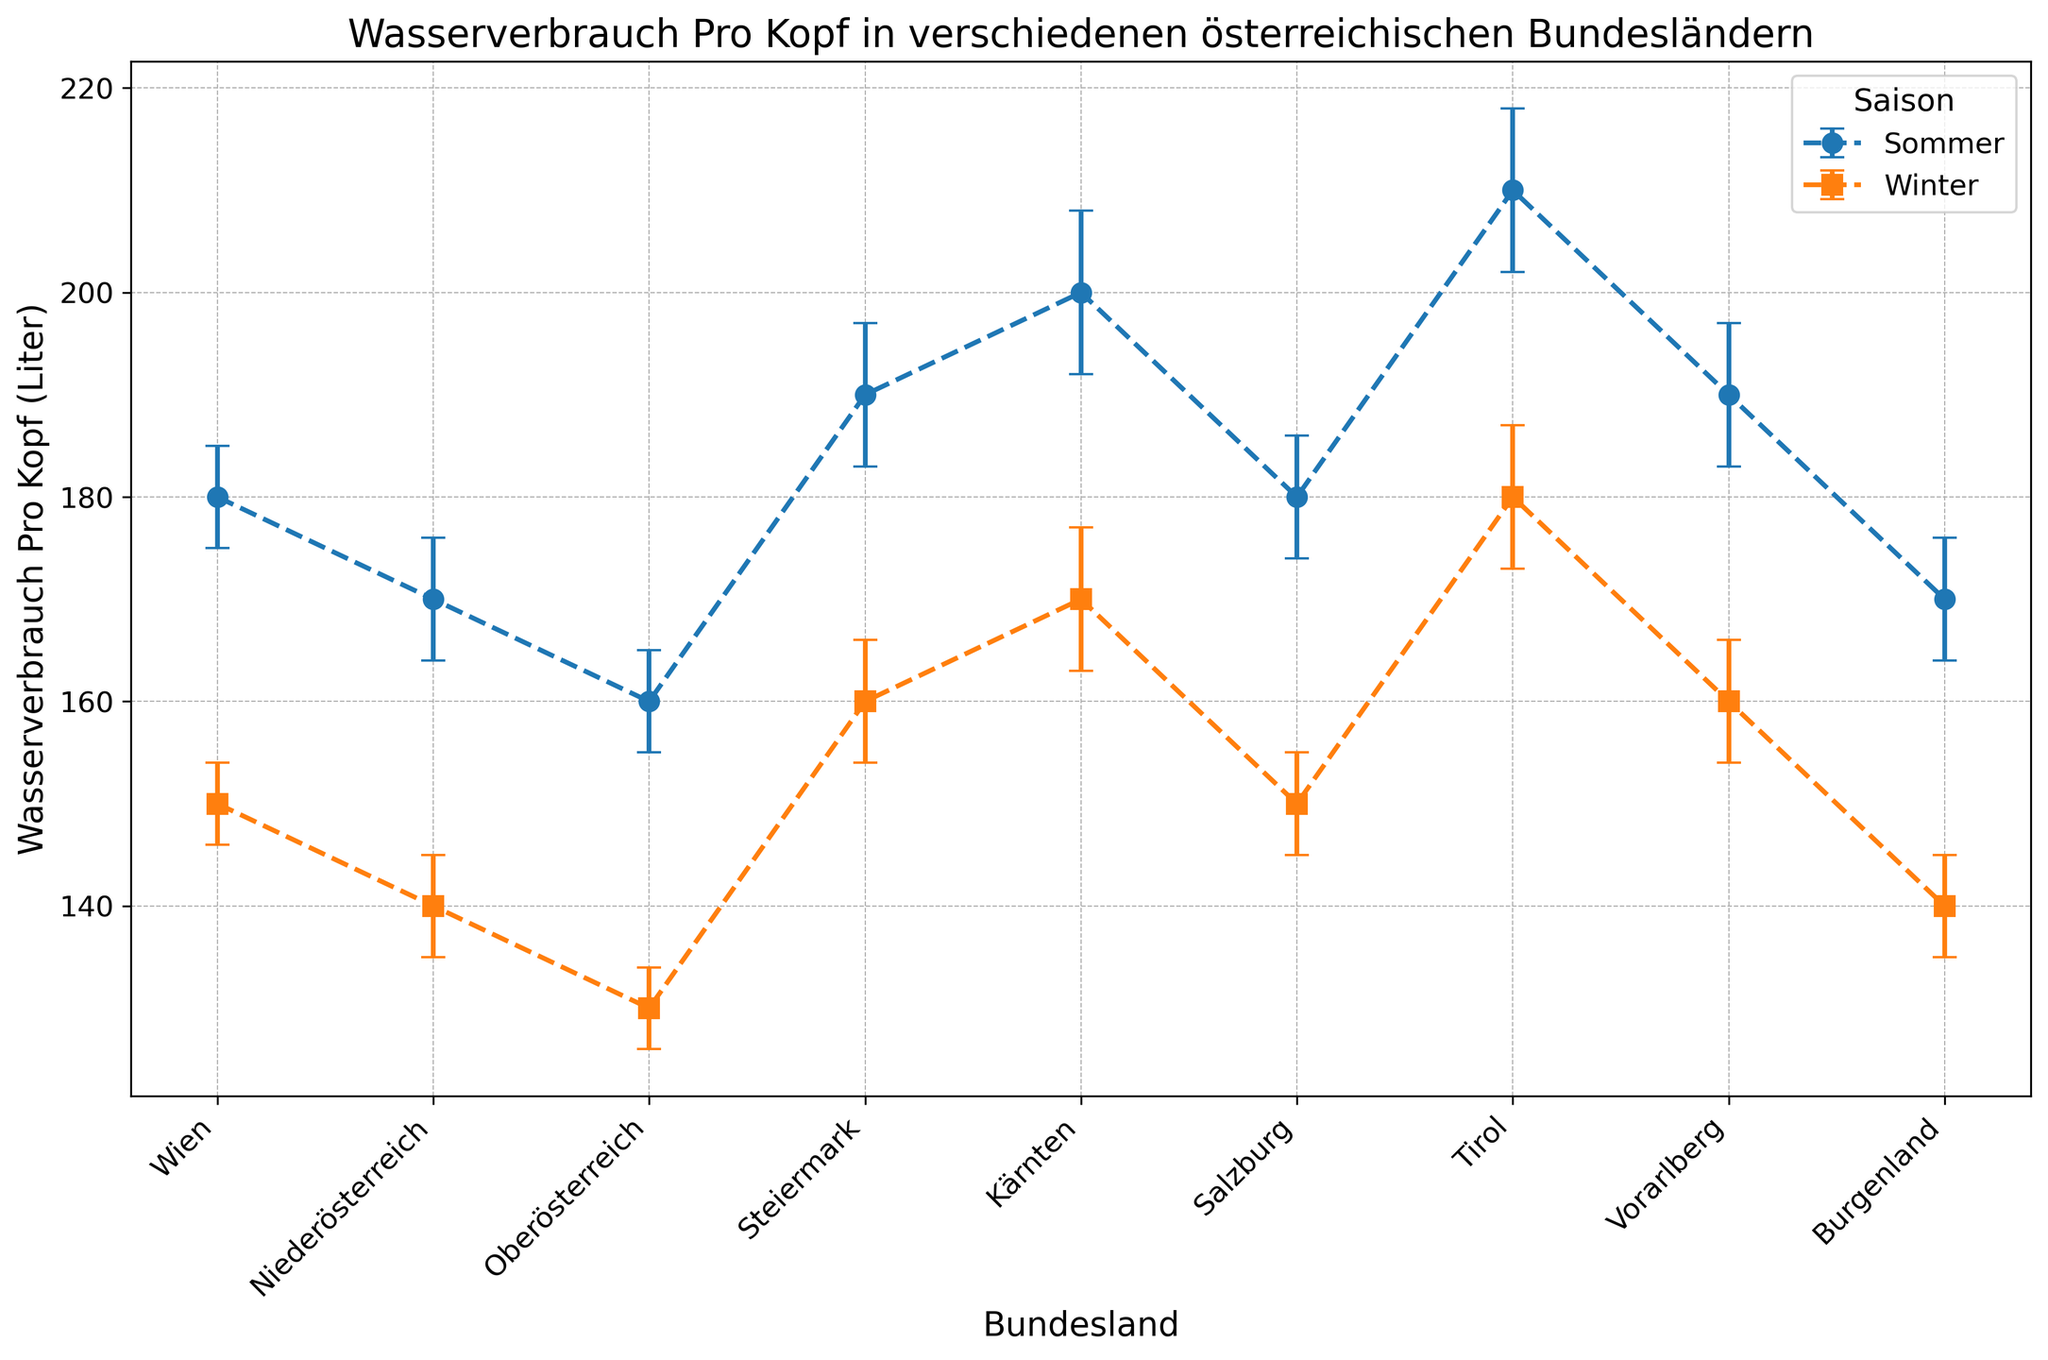Which Bundesland has the highest water consumption per capita in summer? To find the highest water consumption per capita in summer, we look at the Sommer series in the figure and identify the Bundesland with the highest point. The highest value is 210 liters in Tirol.
Answer: Tirol What is the difference in water consumption per capita between summer and winter for Wien? Identify Wien's water consumption values for both seasons: 180 liters in summer and 150 liters in winter. The difference is 180 - 150 = 30 liters.
Answer: 30 liters Which season shows generally higher water consumption per capita across most Bundesländer? By comparing the markers, we observe that the Sommer (blue circles) values are generally higher than the Winter (orange squares) values across most Bundesländer.
Answer: Sommer Which Bundesland shows the smallest difference in water consumption per capita between summer and winter? Calculate the absolute difference for each Bundesland and find the smallest value. Wien has the smallest difference: 180 (Sommer) - 150 (Winter) = 30 liters. Other differences are larger.
Answer: Wien What is the average water consumption per capita in winter for all Bundesländer? Sum the water consumption values for Winter across all Bundesländer and divide by the number of Bundesländer. Summing (150 + 140 + 130 + 160 + 170 + 150 + 180 + 160 + 140) = 1380, and there are 9 Bundesländer, so 1380 / 9 = 153.3 liters.
Answer: 153.3 liters Which Bundesland has the largest error margin in their water consumption per capita measurements? Find the largest error margin value in the figure. The largest error margin is 8 liters, occurring in Kärnten and Tirol during summer.
Answer: Kärnten and Tirol (Sommer) How much higher is the water consumption per capita in Tirol in summer compared to Burgenland in winter? Identify the values: 210 liters for Tirol in summer and 140 liters for Burgenland in winter. The difference is 210 - 140 = 70 liters.
Answer: 70 liters Which Bundesland has equal water consumption per capita in summer and winter? Check if any Bundesland has the same value for both seasons. None of the Bundesländer have equal values for summer and winter in the chart.
Answer: None 